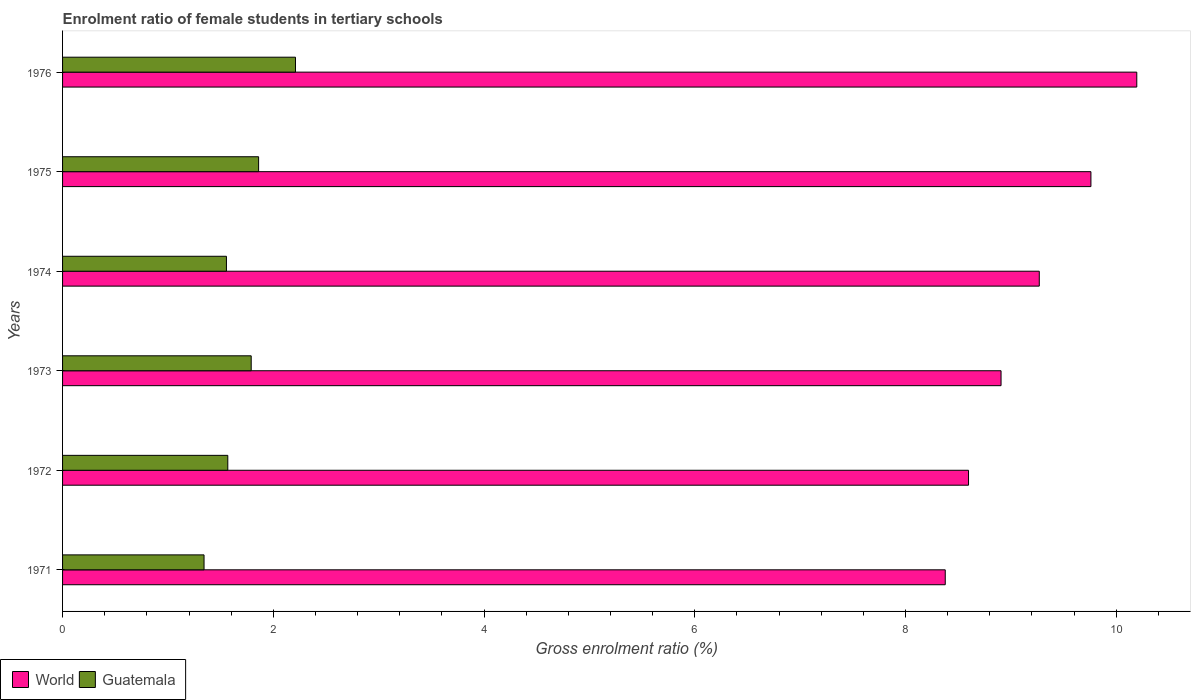Are the number of bars per tick equal to the number of legend labels?
Keep it short and to the point. Yes. How many bars are there on the 5th tick from the top?
Give a very brief answer. 2. What is the label of the 3rd group of bars from the top?
Make the answer very short. 1974. What is the enrolment ratio of female students in tertiary schools in World in 1972?
Give a very brief answer. 8.6. Across all years, what is the maximum enrolment ratio of female students in tertiary schools in Guatemala?
Your answer should be compact. 2.21. Across all years, what is the minimum enrolment ratio of female students in tertiary schools in World?
Make the answer very short. 8.38. In which year was the enrolment ratio of female students in tertiary schools in Guatemala maximum?
Your answer should be very brief. 1976. What is the total enrolment ratio of female students in tertiary schools in World in the graph?
Your answer should be very brief. 55.11. What is the difference between the enrolment ratio of female students in tertiary schools in Guatemala in 1972 and that in 1975?
Give a very brief answer. -0.29. What is the difference between the enrolment ratio of female students in tertiary schools in World in 1975 and the enrolment ratio of female students in tertiary schools in Guatemala in 1974?
Offer a terse response. 8.2. What is the average enrolment ratio of female students in tertiary schools in World per year?
Provide a short and direct response. 9.18. In the year 1975, what is the difference between the enrolment ratio of female students in tertiary schools in World and enrolment ratio of female students in tertiary schools in Guatemala?
Make the answer very short. 7.9. What is the ratio of the enrolment ratio of female students in tertiary schools in Guatemala in 1973 to that in 1974?
Your response must be concise. 1.15. What is the difference between the highest and the second highest enrolment ratio of female students in tertiary schools in World?
Make the answer very short. 0.44. What is the difference between the highest and the lowest enrolment ratio of female students in tertiary schools in World?
Your answer should be compact. 1.82. What does the 1st bar from the top in 1972 represents?
Offer a very short reply. Guatemala. What does the 2nd bar from the bottom in 1973 represents?
Keep it short and to the point. Guatemala. How many bars are there?
Offer a terse response. 12. Are the values on the major ticks of X-axis written in scientific E-notation?
Provide a short and direct response. No. Does the graph contain any zero values?
Provide a short and direct response. No. Where does the legend appear in the graph?
Make the answer very short. Bottom left. How are the legend labels stacked?
Provide a succinct answer. Horizontal. What is the title of the graph?
Make the answer very short. Enrolment ratio of female students in tertiary schools. What is the Gross enrolment ratio (%) in World in 1971?
Offer a terse response. 8.38. What is the Gross enrolment ratio (%) in Guatemala in 1971?
Offer a very short reply. 1.34. What is the Gross enrolment ratio (%) in World in 1972?
Your answer should be compact. 8.6. What is the Gross enrolment ratio (%) in Guatemala in 1972?
Make the answer very short. 1.57. What is the Gross enrolment ratio (%) of World in 1973?
Provide a succinct answer. 8.91. What is the Gross enrolment ratio (%) of Guatemala in 1973?
Offer a very short reply. 1.79. What is the Gross enrolment ratio (%) of World in 1974?
Keep it short and to the point. 9.27. What is the Gross enrolment ratio (%) of Guatemala in 1974?
Your response must be concise. 1.56. What is the Gross enrolment ratio (%) of World in 1975?
Provide a succinct answer. 9.76. What is the Gross enrolment ratio (%) in Guatemala in 1975?
Provide a succinct answer. 1.86. What is the Gross enrolment ratio (%) of World in 1976?
Provide a short and direct response. 10.2. What is the Gross enrolment ratio (%) of Guatemala in 1976?
Ensure brevity in your answer.  2.21. Across all years, what is the maximum Gross enrolment ratio (%) of World?
Offer a terse response. 10.2. Across all years, what is the maximum Gross enrolment ratio (%) in Guatemala?
Your answer should be compact. 2.21. Across all years, what is the minimum Gross enrolment ratio (%) in World?
Ensure brevity in your answer.  8.38. Across all years, what is the minimum Gross enrolment ratio (%) of Guatemala?
Keep it short and to the point. 1.34. What is the total Gross enrolment ratio (%) of World in the graph?
Keep it short and to the point. 55.11. What is the total Gross enrolment ratio (%) in Guatemala in the graph?
Keep it short and to the point. 10.33. What is the difference between the Gross enrolment ratio (%) of World in 1971 and that in 1972?
Provide a succinct answer. -0.22. What is the difference between the Gross enrolment ratio (%) of Guatemala in 1971 and that in 1972?
Your answer should be very brief. -0.23. What is the difference between the Gross enrolment ratio (%) of World in 1971 and that in 1973?
Your answer should be compact. -0.53. What is the difference between the Gross enrolment ratio (%) of Guatemala in 1971 and that in 1973?
Ensure brevity in your answer.  -0.45. What is the difference between the Gross enrolment ratio (%) in World in 1971 and that in 1974?
Offer a very short reply. -0.89. What is the difference between the Gross enrolment ratio (%) in Guatemala in 1971 and that in 1974?
Offer a terse response. -0.21. What is the difference between the Gross enrolment ratio (%) in World in 1971 and that in 1975?
Your answer should be very brief. -1.38. What is the difference between the Gross enrolment ratio (%) in Guatemala in 1971 and that in 1975?
Offer a terse response. -0.52. What is the difference between the Gross enrolment ratio (%) of World in 1971 and that in 1976?
Your response must be concise. -1.82. What is the difference between the Gross enrolment ratio (%) of Guatemala in 1971 and that in 1976?
Offer a very short reply. -0.87. What is the difference between the Gross enrolment ratio (%) of World in 1972 and that in 1973?
Your answer should be compact. -0.31. What is the difference between the Gross enrolment ratio (%) in Guatemala in 1972 and that in 1973?
Offer a very short reply. -0.22. What is the difference between the Gross enrolment ratio (%) in World in 1972 and that in 1974?
Give a very brief answer. -0.67. What is the difference between the Gross enrolment ratio (%) of Guatemala in 1972 and that in 1974?
Offer a very short reply. 0.01. What is the difference between the Gross enrolment ratio (%) of World in 1972 and that in 1975?
Provide a succinct answer. -1.16. What is the difference between the Gross enrolment ratio (%) of Guatemala in 1972 and that in 1975?
Make the answer very short. -0.29. What is the difference between the Gross enrolment ratio (%) of World in 1972 and that in 1976?
Offer a terse response. -1.6. What is the difference between the Gross enrolment ratio (%) in Guatemala in 1972 and that in 1976?
Offer a terse response. -0.64. What is the difference between the Gross enrolment ratio (%) in World in 1973 and that in 1974?
Offer a very short reply. -0.36. What is the difference between the Gross enrolment ratio (%) in Guatemala in 1973 and that in 1974?
Your answer should be compact. 0.24. What is the difference between the Gross enrolment ratio (%) in World in 1973 and that in 1975?
Your answer should be very brief. -0.85. What is the difference between the Gross enrolment ratio (%) of Guatemala in 1973 and that in 1975?
Give a very brief answer. -0.07. What is the difference between the Gross enrolment ratio (%) of World in 1973 and that in 1976?
Keep it short and to the point. -1.29. What is the difference between the Gross enrolment ratio (%) in Guatemala in 1973 and that in 1976?
Give a very brief answer. -0.42. What is the difference between the Gross enrolment ratio (%) of World in 1974 and that in 1975?
Your response must be concise. -0.49. What is the difference between the Gross enrolment ratio (%) in Guatemala in 1974 and that in 1975?
Make the answer very short. -0.31. What is the difference between the Gross enrolment ratio (%) in World in 1974 and that in 1976?
Offer a very short reply. -0.93. What is the difference between the Gross enrolment ratio (%) in Guatemala in 1974 and that in 1976?
Keep it short and to the point. -0.66. What is the difference between the Gross enrolment ratio (%) of World in 1975 and that in 1976?
Your response must be concise. -0.44. What is the difference between the Gross enrolment ratio (%) of Guatemala in 1975 and that in 1976?
Provide a short and direct response. -0.35. What is the difference between the Gross enrolment ratio (%) in World in 1971 and the Gross enrolment ratio (%) in Guatemala in 1972?
Provide a succinct answer. 6.81. What is the difference between the Gross enrolment ratio (%) in World in 1971 and the Gross enrolment ratio (%) in Guatemala in 1973?
Your answer should be very brief. 6.59. What is the difference between the Gross enrolment ratio (%) of World in 1971 and the Gross enrolment ratio (%) of Guatemala in 1974?
Provide a short and direct response. 6.82. What is the difference between the Gross enrolment ratio (%) of World in 1971 and the Gross enrolment ratio (%) of Guatemala in 1975?
Offer a very short reply. 6.52. What is the difference between the Gross enrolment ratio (%) in World in 1971 and the Gross enrolment ratio (%) in Guatemala in 1976?
Give a very brief answer. 6.17. What is the difference between the Gross enrolment ratio (%) of World in 1972 and the Gross enrolment ratio (%) of Guatemala in 1973?
Provide a short and direct response. 6.81. What is the difference between the Gross enrolment ratio (%) of World in 1972 and the Gross enrolment ratio (%) of Guatemala in 1974?
Your answer should be very brief. 7.04. What is the difference between the Gross enrolment ratio (%) of World in 1972 and the Gross enrolment ratio (%) of Guatemala in 1975?
Give a very brief answer. 6.74. What is the difference between the Gross enrolment ratio (%) of World in 1972 and the Gross enrolment ratio (%) of Guatemala in 1976?
Provide a succinct answer. 6.39. What is the difference between the Gross enrolment ratio (%) in World in 1973 and the Gross enrolment ratio (%) in Guatemala in 1974?
Your answer should be very brief. 7.35. What is the difference between the Gross enrolment ratio (%) in World in 1973 and the Gross enrolment ratio (%) in Guatemala in 1975?
Make the answer very short. 7.05. What is the difference between the Gross enrolment ratio (%) of World in 1973 and the Gross enrolment ratio (%) of Guatemala in 1976?
Ensure brevity in your answer.  6.7. What is the difference between the Gross enrolment ratio (%) in World in 1974 and the Gross enrolment ratio (%) in Guatemala in 1975?
Offer a very short reply. 7.41. What is the difference between the Gross enrolment ratio (%) of World in 1974 and the Gross enrolment ratio (%) of Guatemala in 1976?
Your answer should be compact. 7.06. What is the difference between the Gross enrolment ratio (%) in World in 1975 and the Gross enrolment ratio (%) in Guatemala in 1976?
Offer a very short reply. 7.55. What is the average Gross enrolment ratio (%) in World per year?
Provide a succinct answer. 9.18. What is the average Gross enrolment ratio (%) in Guatemala per year?
Give a very brief answer. 1.72. In the year 1971, what is the difference between the Gross enrolment ratio (%) in World and Gross enrolment ratio (%) in Guatemala?
Make the answer very short. 7.03. In the year 1972, what is the difference between the Gross enrolment ratio (%) of World and Gross enrolment ratio (%) of Guatemala?
Your answer should be very brief. 7.03. In the year 1973, what is the difference between the Gross enrolment ratio (%) of World and Gross enrolment ratio (%) of Guatemala?
Make the answer very short. 7.12. In the year 1974, what is the difference between the Gross enrolment ratio (%) in World and Gross enrolment ratio (%) in Guatemala?
Keep it short and to the point. 7.71. In the year 1975, what is the difference between the Gross enrolment ratio (%) in World and Gross enrolment ratio (%) in Guatemala?
Ensure brevity in your answer.  7.9. In the year 1976, what is the difference between the Gross enrolment ratio (%) of World and Gross enrolment ratio (%) of Guatemala?
Provide a short and direct response. 7.98. What is the ratio of the Gross enrolment ratio (%) of World in 1971 to that in 1972?
Your answer should be very brief. 0.97. What is the ratio of the Gross enrolment ratio (%) of Guatemala in 1971 to that in 1972?
Your answer should be very brief. 0.86. What is the ratio of the Gross enrolment ratio (%) of World in 1971 to that in 1973?
Offer a terse response. 0.94. What is the ratio of the Gross enrolment ratio (%) in Guatemala in 1971 to that in 1973?
Give a very brief answer. 0.75. What is the ratio of the Gross enrolment ratio (%) of World in 1971 to that in 1974?
Make the answer very short. 0.9. What is the ratio of the Gross enrolment ratio (%) in Guatemala in 1971 to that in 1974?
Offer a terse response. 0.86. What is the ratio of the Gross enrolment ratio (%) of World in 1971 to that in 1975?
Make the answer very short. 0.86. What is the ratio of the Gross enrolment ratio (%) in Guatemala in 1971 to that in 1975?
Your answer should be compact. 0.72. What is the ratio of the Gross enrolment ratio (%) of World in 1971 to that in 1976?
Provide a short and direct response. 0.82. What is the ratio of the Gross enrolment ratio (%) in Guatemala in 1971 to that in 1976?
Offer a terse response. 0.61. What is the ratio of the Gross enrolment ratio (%) of World in 1972 to that in 1973?
Your answer should be compact. 0.97. What is the ratio of the Gross enrolment ratio (%) in Guatemala in 1972 to that in 1973?
Ensure brevity in your answer.  0.88. What is the ratio of the Gross enrolment ratio (%) of World in 1972 to that in 1974?
Give a very brief answer. 0.93. What is the ratio of the Gross enrolment ratio (%) of Guatemala in 1972 to that in 1974?
Your answer should be very brief. 1.01. What is the ratio of the Gross enrolment ratio (%) of World in 1972 to that in 1975?
Offer a very short reply. 0.88. What is the ratio of the Gross enrolment ratio (%) of Guatemala in 1972 to that in 1975?
Make the answer very short. 0.84. What is the ratio of the Gross enrolment ratio (%) in World in 1972 to that in 1976?
Offer a very short reply. 0.84. What is the ratio of the Gross enrolment ratio (%) of Guatemala in 1972 to that in 1976?
Give a very brief answer. 0.71. What is the ratio of the Gross enrolment ratio (%) of World in 1973 to that in 1974?
Offer a very short reply. 0.96. What is the ratio of the Gross enrolment ratio (%) in Guatemala in 1973 to that in 1974?
Keep it short and to the point. 1.15. What is the ratio of the Gross enrolment ratio (%) in World in 1973 to that in 1975?
Give a very brief answer. 0.91. What is the ratio of the Gross enrolment ratio (%) in Guatemala in 1973 to that in 1975?
Make the answer very short. 0.96. What is the ratio of the Gross enrolment ratio (%) in World in 1973 to that in 1976?
Ensure brevity in your answer.  0.87. What is the ratio of the Gross enrolment ratio (%) in Guatemala in 1973 to that in 1976?
Offer a terse response. 0.81. What is the ratio of the Gross enrolment ratio (%) of World in 1974 to that in 1975?
Your answer should be very brief. 0.95. What is the ratio of the Gross enrolment ratio (%) of Guatemala in 1974 to that in 1975?
Offer a terse response. 0.84. What is the ratio of the Gross enrolment ratio (%) in World in 1974 to that in 1976?
Provide a short and direct response. 0.91. What is the ratio of the Gross enrolment ratio (%) in Guatemala in 1974 to that in 1976?
Your answer should be very brief. 0.7. What is the ratio of the Gross enrolment ratio (%) in World in 1975 to that in 1976?
Ensure brevity in your answer.  0.96. What is the ratio of the Gross enrolment ratio (%) in Guatemala in 1975 to that in 1976?
Offer a terse response. 0.84. What is the difference between the highest and the second highest Gross enrolment ratio (%) in World?
Keep it short and to the point. 0.44. What is the difference between the highest and the lowest Gross enrolment ratio (%) in World?
Offer a terse response. 1.82. What is the difference between the highest and the lowest Gross enrolment ratio (%) in Guatemala?
Your answer should be very brief. 0.87. 